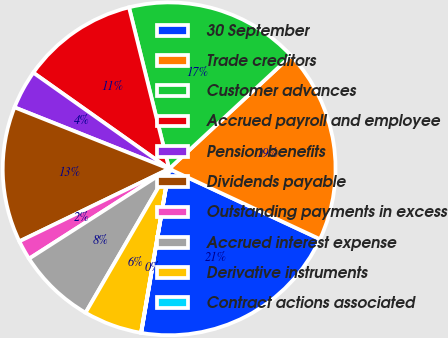Convert chart to OTSL. <chart><loc_0><loc_0><loc_500><loc_500><pie_chart><fcel>30 September<fcel>Trade creditors<fcel>Customer advances<fcel>Accrued payroll and employee<fcel>Pension benefits<fcel>Dividends payable<fcel>Outstanding payments in excess<fcel>Accrued interest expense<fcel>Derivative instruments<fcel>Contract actions associated<nl><fcel>20.74%<fcel>18.85%<fcel>16.97%<fcel>11.32%<fcel>3.78%<fcel>13.2%<fcel>1.9%<fcel>7.55%<fcel>5.67%<fcel>0.02%<nl></chart> 